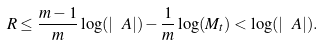<formula> <loc_0><loc_0><loc_500><loc_500>R \leq \frac { m - 1 } { m } \log ( | \ A | ) - \frac { 1 } { m } \log ( M _ { t } ) < \log ( | \ A | ) .</formula> 